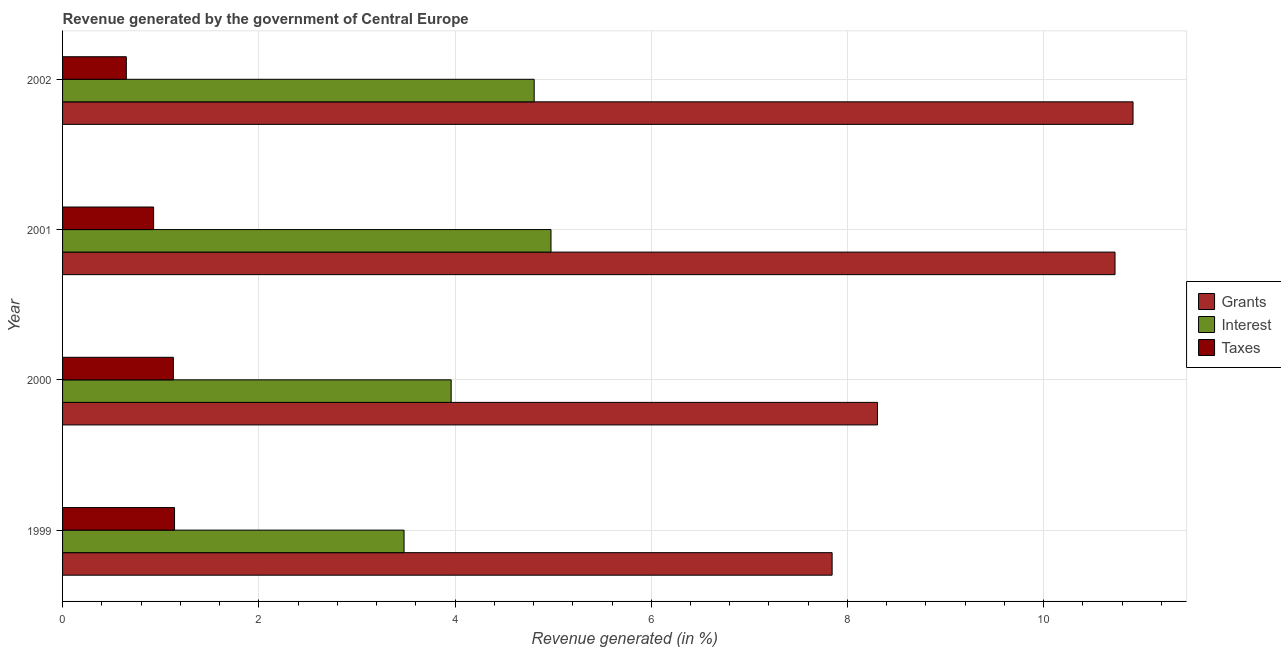How many different coloured bars are there?
Give a very brief answer. 3. How many bars are there on the 2nd tick from the top?
Give a very brief answer. 3. What is the label of the 3rd group of bars from the top?
Ensure brevity in your answer.  2000. In how many cases, is the number of bars for a given year not equal to the number of legend labels?
Make the answer very short. 0. What is the percentage of revenue generated by grants in 2001?
Keep it short and to the point. 10.73. Across all years, what is the maximum percentage of revenue generated by grants?
Keep it short and to the point. 10.91. Across all years, what is the minimum percentage of revenue generated by interest?
Make the answer very short. 3.48. In which year was the percentage of revenue generated by grants minimum?
Provide a succinct answer. 1999. What is the total percentage of revenue generated by interest in the graph?
Your response must be concise. 17.23. What is the difference between the percentage of revenue generated by taxes in 1999 and that in 2000?
Offer a very short reply. 0.01. What is the difference between the percentage of revenue generated by grants in 2001 and the percentage of revenue generated by taxes in 1999?
Make the answer very short. 9.59. What is the average percentage of revenue generated by interest per year?
Provide a succinct answer. 4.31. In the year 1999, what is the difference between the percentage of revenue generated by interest and percentage of revenue generated by taxes?
Your answer should be very brief. 2.34. In how many years, is the percentage of revenue generated by taxes greater than 10 %?
Provide a short and direct response. 0. What is the ratio of the percentage of revenue generated by interest in 1999 to that in 2001?
Your answer should be very brief. 0.7. What is the difference between the highest and the second highest percentage of revenue generated by interest?
Your answer should be very brief. 0.17. What is the difference between the highest and the lowest percentage of revenue generated by grants?
Your response must be concise. 3.07. Is the sum of the percentage of revenue generated by interest in 1999 and 2002 greater than the maximum percentage of revenue generated by taxes across all years?
Ensure brevity in your answer.  Yes. What does the 3rd bar from the top in 2000 represents?
Give a very brief answer. Grants. What does the 2nd bar from the bottom in 2001 represents?
Your answer should be very brief. Interest. Is it the case that in every year, the sum of the percentage of revenue generated by grants and percentage of revenue generated by interest is greater than the percentage of revenue generated by taxes?
Your answer should be very brief. Yes. How many bars are there?
Keep it short and to the point. 12. Are all the bars in the graph horizontal?
Offer a terse response. Yes. How many years are there in the graph?
Your answer should be compact. 4. Are the values on the major ticks of X-axis written in scientific E-notation?
Offer a very short reply. No. Does the graph contain any zero values?
Offer a terse response. No. Does the graph contain grids?
Make the answer very short. Yes. Where does the legend appear in the graph?
Ensure brevity in your answer.  Center right. How many legend labels are there?
Make the answer very short. 3. How are the legend labels stacked?
Offer a terse response. Vertical. What is the title of the graph?
Provide a succinct answer. Revenue generated by the government of Central Europe. What is the label or title of the X-axis?
Your answer should be very brief. Revenue generated (in %). What is the label or title of the Y-axis?
Provide a succinct answer. Year. What is the Revenue generated (in %) in Grants in 1999?
Offer a terse response. 7.84. What is the Revenue generated (in %) of Interest in 1999?
Provide a succinct answer. 3.48. What is the Revenue generated (in %) in Taxes in 1999?
Give a very brief answer. 1.14. What is the Revenue generated (in %) of Grants in 2000?
Keep it short and to the point. 8.31. What is the Revenue generated (in %) in Interest in 2000?
Provide a short and direct response. 3.96. What is the Revenue generated (in %) in Taxes in 2000?
Ensure brevity in your answer.  1.13. What is the Revenue generated (in %) of Grants in 2001?
Give a very brief answer. 10.73. What is the Revenue generated (in %) in Interest in 2001?
Your answer should be compact. 4.98. What is the Revenue generated (in %) of Taxes in 2001?
Provide a succinct answer. 0.93. What is the Revenue generated (in %) in Grants in 2002?
Provide a short and direct response. 10.91. What is the Revenue generated (in %) in Interest in 2002?
Give a very brief answer. 4.81. What is the Revenue generated (in %) in Taxes in 2002?
Provide a short and direct response. 0.65. Across all years, what is the maximum Revenue generated (in %) in Grants?
Your response must be concise. 10.91. Across all years, what is the maximum Revenue generated (in %) of Interest?
Provide a succinct answer. 4.98. Across all years, what is the maximum Revenue generated (in %) in Taxes?
Provide a succinct answer. 1.14. Across all years, what is the minimum Revenue generated (in %) in Grants?
Give a very brief answer. 7.84. Across all years, what is the minimum Revenue generated (in %) of Interest?
Your answer should be very brief. 3.48. Across all years, what is the minimum Revenue generated (in %) in Taxes?
Offer a very short reply. 0.65. What is the total Revenue generated (in %) in Grants in the graph?
Keep it short and to the point. 37.79. What is the total Revenue generated (in %) of Interest in the graph?
Give a very brief answer. 17.23. What is the total Revenue generated (in %) in Taxes in the graph?
Offer a very short reply. 3.85. What is the difference between the Revenue generated (in %) in Grants in 1999 and that in 2000?
Ensure brevity in your answer.  -0.46. What is the difference between the Revenue generated (in %) of Interest in 1999 and that in 2000?
Give a very brief answer. -0.48. What is the difference between the Revenue generated (in %) of Taxes in 1999 and that in 2000?
Give a very brief answer. 0.01. What is the difference between the Revenue generated (in %) in Grants in 1999 and that in 2001?
Your answer should be very brief. -2.88. What is the difference between the Revenue generated (in %) in Interest in 1999 and that in 2001?
Give a very brief answer. -1.5. What is the difference between the Revenue generated (in %) in Taxes in 1999 and that in 2001?
Provide a short and direct response. 0.21. What is the difference between the Revenue generated (in %) of Grants in 1999 and that in 2002?
Your answer should be compact. -3.07. What is the difference between the Revenue generated (in %) in Interest in 1999 and that in 2002?
Offer a terse response. -1.33. What is the difference between the Revenue generated (in %) in Taxes in 1999 and that in 2002?
Make the answer very short. 0.49. What is the difference between the Revenue generated (in %) in Grants in 2000 and that in 2001?
Offer a terse response. -2.42. What is the difference between the Revenue generated (in %) in Interest in 2000 and that in 2001?
Your answer should be very brief. -1.02. What is the difference between the Revenue generated (in %) of Taxes in 2000 and that in 2001?
Offer a very short reply. 0.2. What is the difference between the Revenue generated (in %) in Grants in 2000 and that in 2002?
Offer a very short reply. -2.6. What is the difference between the Revenue generated (in %) of Interest in 2000 and that in 2002?
Keep it short and to the point. -0.85. What is the difference between the Revenue generated (in %) in Taxes in 2000 and that in 2002?
Keep it short and to the point. 0.48. What is the difference between the Revenue generated (in %) in Grants in 2001 and that in 2002?
Make the answer very short. -0.18. What is the difference between the Revenue generated (in %) of Interest in 2001 and that in 2002?
Ensure brevity in your answer.  0.17. What is the difference between the Revenue generated (in %) of Taxes in 2001 and that in 2002?
Keep it short and to the point. 0.28. What is the difference between the Revenue generated (in %) of Grants in 1999 and the Revenue generated (in %) of Interest in 2000?
Give a very brief answer. 3.88. What is the difference between the Revenue generated (in %) of Grants in 1999 and the Revenue generated (in %) of Taxes in 2000?
Provide a succinct answer. 6.71. What is the difference between the Revenue generated (in %) of Interest in 1999 and the Revenue generated (in %) of Taxes in 2000?
Your answer should be compact. 2.35. What is the difference between the Revenue generated (in %) in Grants in 1999 and the Revenue generated (in %) in Interest in 2001?
Your answer should be very brief. 2.87. What is the difference between the Revenue generated (in %) of Grants in 1999 and the Revenue generated (in %) of Taxes in 2001?
Offer a terse response. 6.92. What is the difference between the Revenue generated (in %) of Interest in 1999 and the Revenue generated (in %) of Taxes in 2001?
Your answer should be compact. 2.55. What is the difference between the Revenue generated (in %) of Grants in 1999 and the Revenue generated (in %) of Interest in 2002?
Make the answer very short. 3.04. What is the difference between the Revenue generated (in %) in Grants in 1999 and the Revenue generated (in %) in Taxes in 2002?
Your answer should be compact. 7.19. What is the difference between the Revenue generated (in %) in Interest in 1999 and the Revenue generated (in %) in Taxes in 2002?
Keep it short and to the point. 2.83. What is the difference between the Revenue generated (in %) of Grants in 2000 and the Revenue generated (in %) of Interest in 2001?
Offer a terse response. 3.33. What is the difference between the Revenue generated (in %) in Grants in 2000 and the Revenue generated (in %) in Taxes in 2001?
Offer a terse response. 7.38. What is the difference between the Revenue generated (in %) of Interest in 2000 and the Revenue generated (in %) of Taxes in 2001?
Offer a terse response. 3.03. What is the difference between the Revenue generated (in %) of Grants in 2000 and the Revenue generated (in %) of Interest in 2002?
Offer a terse response. 3.5. What is the difference between the Revenue generated (in %) of Grants in 2000 and the Revenue generated (in %) of Taxes in 2002?
Your answer should be compact. 7.66. What is the difference between the Revenue generated (in %) of Interest in 2000 and the Revenue generated (in %) of Taxes in 2002?
Your answer should be compact. 3.31. What is the difference between the Revenue generated (in %) in Grants in 2001 and the Revenue generated (in %) in Interest in 2002?
Give a very brief answer. 5.92. What is the difference between the Revenue generated (in %) in Grants in 2001 and the Revenue generated (in %) in Taxes in 2002?
Your response must be concise. 10.08. What is the difference between the Revenue generated (in %) in Interest in 2001 and the Revenue generated (in %) in Taxes in 2002?
Your answer should be compact. 4.33. What is the average Revenue generated (in %) of Grants per year?
Your response must be concise. 9.45. What is the average Revenue generated (in %) in Interest per year?
Your answer should be compact. 4.31. What is the average Revenue generated (in %) of Taxes per year?
Keep it short and to the point. 0.96. In the year 1999, what is the difference between the Revenue generated (in %) of Grants and Revenue generated (in %) of Interest?
Your answer should be very brief. 4.36. In the year 1999, what is the difference between the Revenue generated (in %) of Grants and Revenue generated (in %) of Taxes?
Your answer should be compact. 6.7. In the year 1999, what is the difference between the Revenue generated (in %) in Interest and Revenue generated (in %) in Taxes?
Your answer should be compact. 2.34. In the year 2000, what is the difference between the Revenue generated (in %) of Grants and Revenue generated (in %) of Interest?
Ensure brevity in your answer.  4.35. In the year 2000, what is the difference between the Revenue generated (in %) in Grants and Revenue generated (in %) in Taxes?
Ensure brevity in your answer.  7.18. In the year 2000, what is the difference between the Revenue generated (in %) in Interest and Revenue generated (in %) in Taxes?
Provide a short and direct response. 2.83. In the year 2001, what is the difference between the Revenue generated (in %) in Grants and Revenue generated (in %) in Interest?
Your answer should be compact. 5.75. In the year 2001, what is the difference between the Revenue generated (in %) of Grants and Revenue generated (in %) of Taxes?
Keep it short and to the point. 9.8. In the year 2001, what is the difference between the Revenue generated (in %) in Interest and Revenue generated (in %) in Taxes?
Your answer should be very brief. 4.05. In the year 2002, what is the difference between the Revenue generated (in %) of Grants and Revenue generated (in %) of Interest?
Your answer should be compact. 6.1. In the year 2002, what is the difference between the Revenue generated (in %) of Grants and Revenue generated (in %) of Taxes?
Your answer should be very brief. 10.26. In the year 2002, what is the difference between the Revenue generated (in %) in Interest and Revenue generated (in %) in Taxes?
Offer a very short reply. 4.16. What is the ratio of the Revenue generated (in %) of Grants in 1999 to that in 2000?
Provide a short and direct response. 0.94. What is the ratio of the Revenue generated (in %) of Interest in 1999 to that in 2000?
Offer a very short reply. 0.88. What is the ratio of the Revenue generated (in %) in Taxes in 1999 to that in 2000?
Provide a succinct answer. 1.01. What is the ratio of the Revenue generated (in %) of Grants in 1999 to that in 2001?
Your response must be concise. 0.73. What is the ratio of the Revenue generated (in %) of Interest in 1999 to that in 2001?
Offer a terse response. 0.7. What is the ratio of the Revenue generated (in %) in Taxes in 1999 to that in 2001?
Provide a short and direct response. 1.23. What is the ratio of the Revenue generated (in %) of Grants in 1999 to that in 2002?
Your answer should be very brief. 0.72. What is the ratio of the Revenue generated (in %) of Interest in 1999 to that in 2002?
Your response must be concise. 0.72. What is the ratio of the Revenue generated (in %) of Taxes in 1999 to that in 2002?
Your answer should be compact. 1.76. What is the ratio of the Revenue generated (in %) of Grants in 2000 to that in 2001?
Give a very brief answer. 0.77. What is the ratio of the Revenue generated (in %) of Interest in 2000 to that in 2001?
Ensure brevity in your answer.  0.8. What is the ratio of the Revenue generated (in %) in Taxes in 2000 to that in 2001?
Offer a terse response. 1.22. What is the ratio of the Revenue generated (in %) in Grants in 2000 to that in 2002?
Your response must be concise. 0.76. What is the ratio of the Revenue generated (in %) in Interest in 2000 to that in 2002?
Provide a short and direct response. 0.82. What is the ratio of the Revenue generated (in %) in Taxes in 2000 to that in 2002?
Your answer should be very brief. 1.74. What is the ratio of the Revenue generated (in %) of Grants in 2001 to that in 2002?
Your response must be concise. 0.98. What is the ratio of the Revenue generated (in %) in Interest in 2001 to that in 2002?
Offer a terse response. 1.04. What is the ratio of the Revenue generated (in %) in Taxes in 2001 to that in 2002?
Keep it short and to the point. 1.43. What is the difference between the highest and the second highest Revenue generated (in %) of Grants?
Offer a very short reply. 0.18. What is the difference between the highest and the second highest Revenue generated (in %) in Interest?
Offer a very short reply. 0.17. What is the difference between the highest and the second highest Revenue generated (in %) of Taxes?
Offer a terse response. 0.01. What is the difference between the highest and the lowest Revenue generated (in %) of Grants?
Offer a terse response. 3.07. What is the difference between the highest and the lowest Revenue generated (in %) of Interest?
Your response must be concise. 1.5. What is the difference between the highest and the lowest Revenue generated (in %) in Taxes?
Make the answer very short. 0.49. 